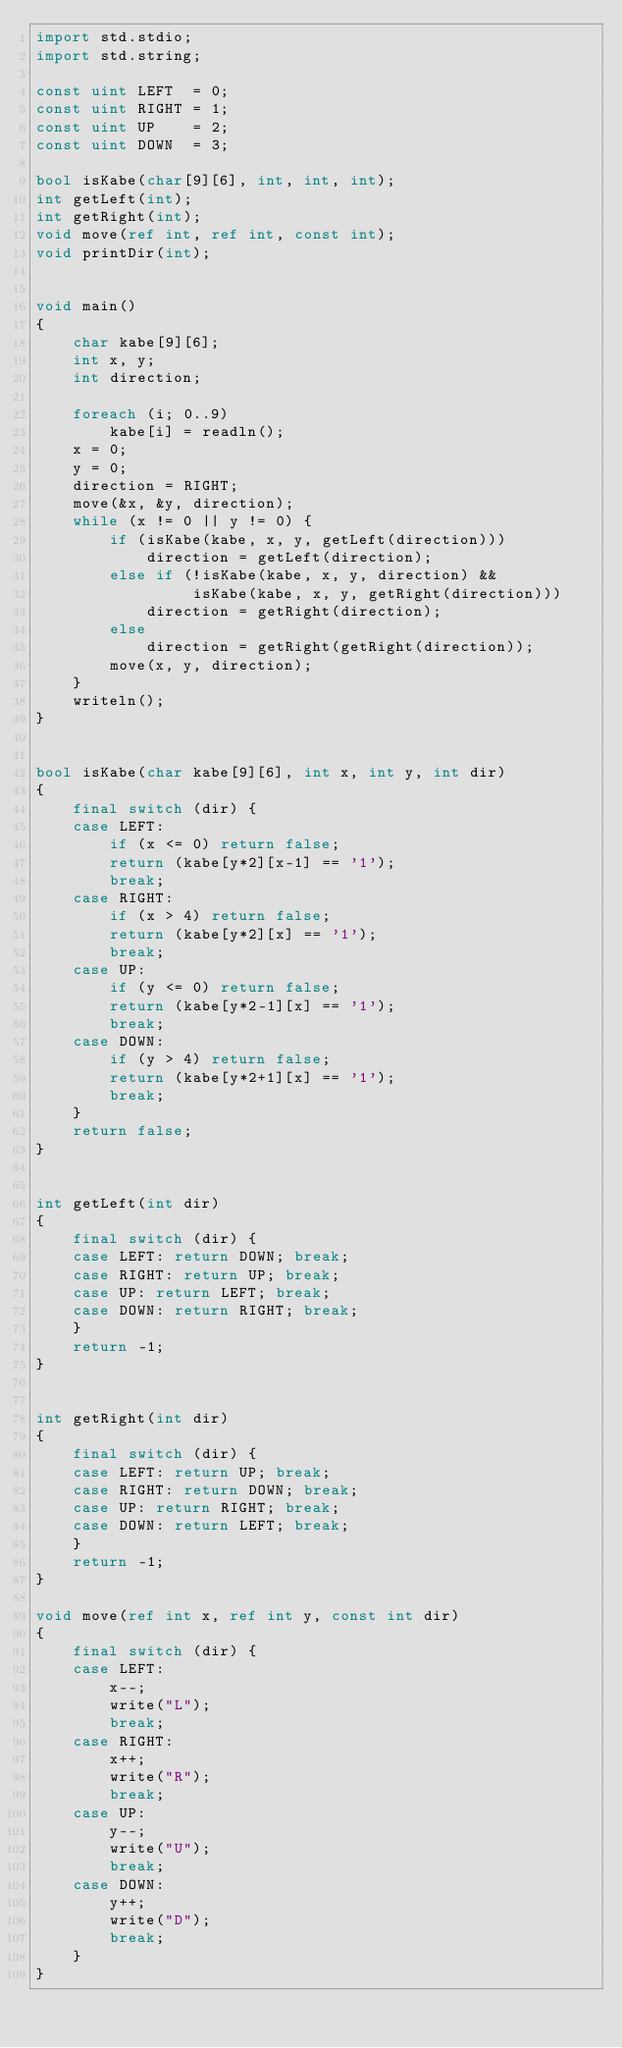<code> <loc_0><loc_0><loc_500><loc_500><_D_>import std.stdio;
import std.string;

const uint LEFT  = 0;
const uint RIGHT = 1;
const uint UP    = 2;
const uint DOWN  = 3;

bool isKabe(char[9][6], int, int, int);
int getLeft(int);
int getRight(int);
void move(ref int, ref int, const int);
void printDir(int);


void main()
{
    char kabe[9][6];
    int x, y;
    int direction;

    foreach (i; 0..9)
        kabe[i] = readln();
    x = 0;
    y = 0;
    direction = RIGHT;
    move(&x, &y, direction);
    while (x != 0 || y != 0) {
        if (isKabe(kabe, x, y, getLeft(direction)))
            direction = getLeft(direction);
        else if (!isKabe(kabe, x, y, direction) &&
                 isKabe(kabe, x, y, getRight(direction)))
            direction = getRight(direction);
        else
            direction = getRight(getRight(direction));
        move(x, y, direction);
    }
    writeln();
}


bool isKabe(char kabe[9][6], int x, int y, int dir)
{
    final switch (dir) {
    case LEFT:
        if (x <= 0) return false;
        return (kabe[y*2][x-1] == '1');
        break;
    case RIGHT:
        if (x > 4) return false;
        return (kabe[y*2][x] == '1');
        break;
    case UP:
        if (y <= 0) return false;
        return (kabe[y*2-1][x] == '1');
        break;
    case DOWN:
        if (y > 4) return false;
        return (kabe[y*2+1][x] == '1');
        break;
    }
    return false;
}


int getLeft(int dir)
{
    final switch (dir) {
    case LEFT: return DOWN; break;
    case RIGHT: return UP; break;
    case UP: return LEFT; break;
    case DOWN: return RIGHT; break;
    }
    return -1;
}


int getRight(int dir)
{
    final switch (dir) {
    case LEFT: return UP; break;
    case RIGHT: return DOWN; break;
    case UP: return RIGHT; break;
    case DOWN: return LEFT; break;
    }
    return -1;
}

void move(ref int x, ref int y, const int dir)
{
    final switch (dir) {
    case LEFT:
        x--;
        write("L");
        break;
    case RIGHT:
        x++;
        write("R");
        break;
    case UP:
        y--;
        write("U");
        break;
    case DOWN:
        y++;
        write("D");
        break;
    }
}</code> 